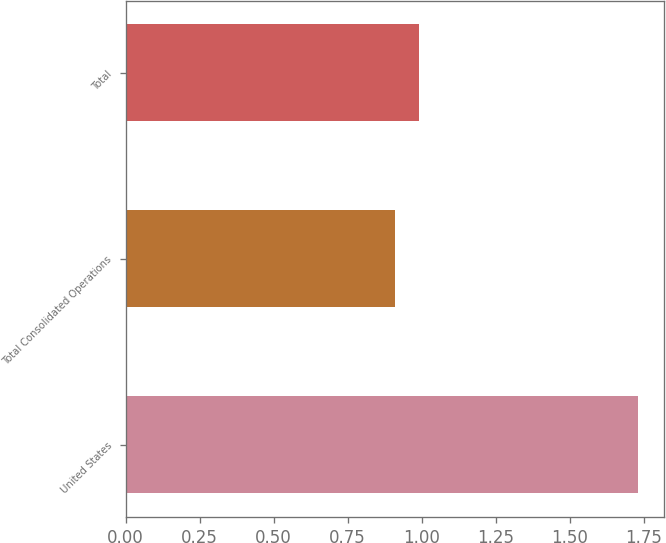Convert chart to OTSL. <chart><loc_0><loc_0><loc_500><loc_500><bar_chart><fcel>United States<fcel>Total Consolidated Operations<fcel>Total<nl><fcel>1.73<fcel>0.91<fcel>0.99<nl></chart> 